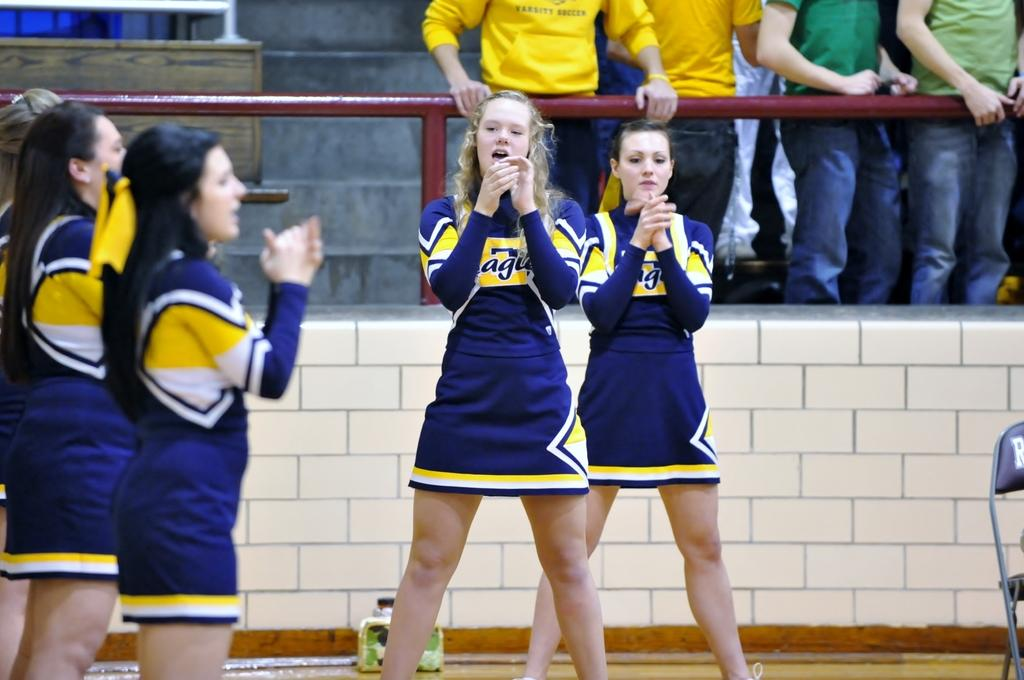<image>
Describe the image concisely. Cheerleaders wear a yellow and navy uniform with the letters agu on them 